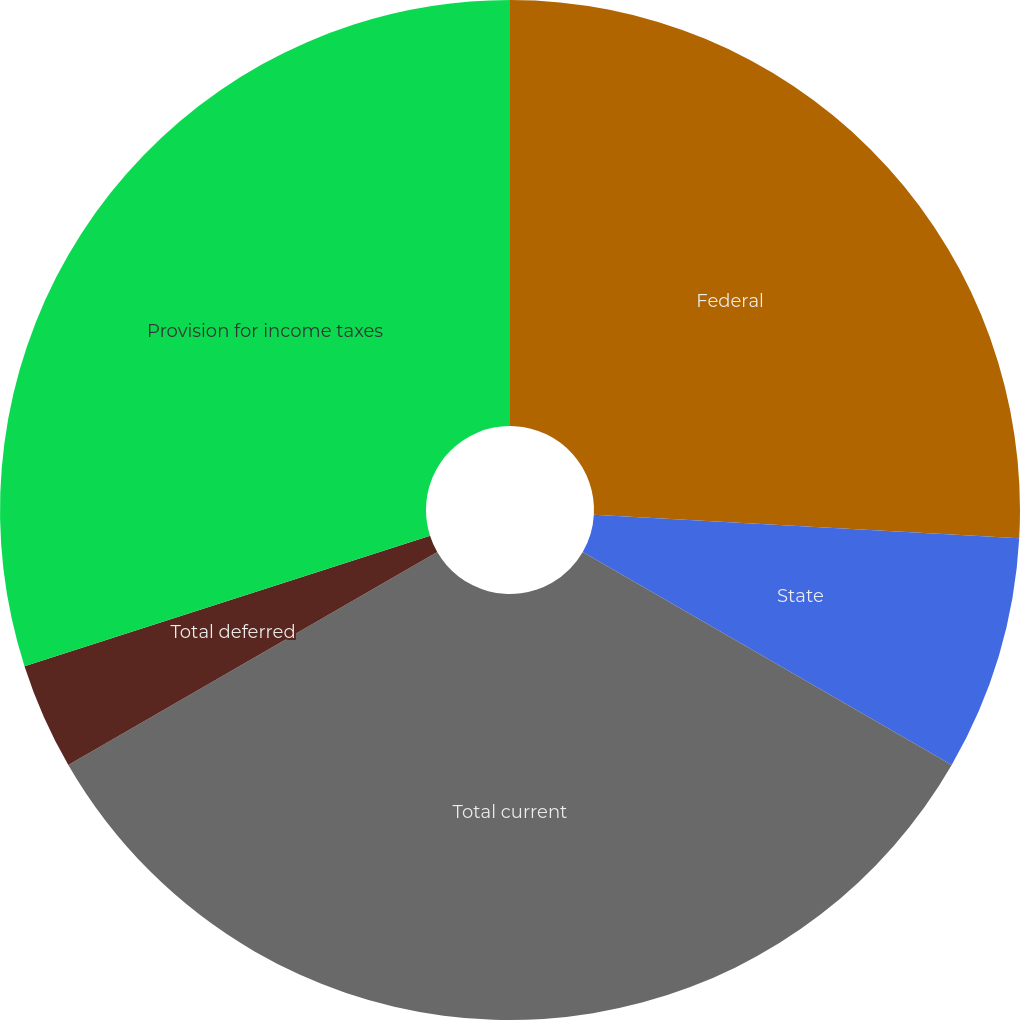<chart> <loc_0><loc_0><loc_500><loc_500><pie_chart><fcel>Federal<fcel>State<fcel>Total current<fcel>Total deferred<fcel>Provision for income taxes<nl><fcel>25.88%<fcel>7.45%<fcel>33.33%<fcel>3.38%<fcel>29.95%<nl></chart> 